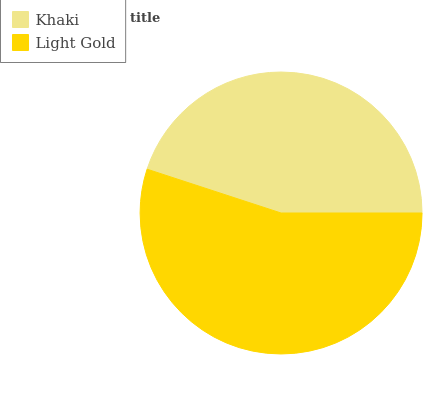Is Khaki the minimum?
Answer yes or no. Yes. Is Light Gold the maximum?
Answer yes or no. Yes. Is Light Gold the minimum?
Answer yes or no. No. Is Light Gold greater than Khaki?
Answer yes or no. Yes. Is Khaki less than Light Gold?
Answer yes or no. Yes. Is Khaki greater than Light Gold?
Answer yes or no. No. Is Light Gold less than Khaki?
Answer yes or no. No. Is Light Gold the high median?
Answer yes or no. Yes. Is Khaki the low median?
Answer yes or no. Yes. Is Khaki the high median?
Answer yes or no. No. Is Light Gold the low median?
Answer yes or no. No. 